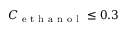<formula> <loc_0><loc_0><loc_500><loc_500>C _ { e t h a n o l } \leq 0 . 3</formula> 